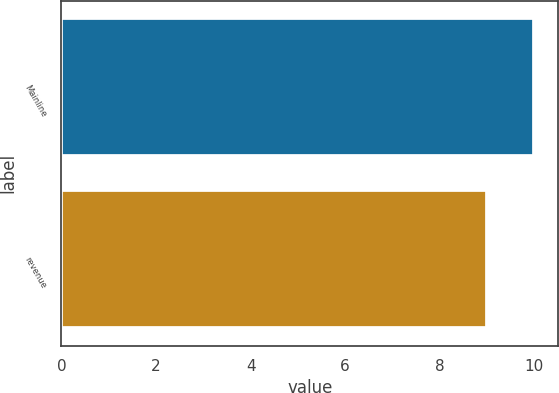Convert chart to OTSL. <chart><loc_0><loc_0><loc_500><loc_500><bar_chart><fcel>Mainline<fcel>revenue<nl><fcel>10<fcel>9<nl></chart> 